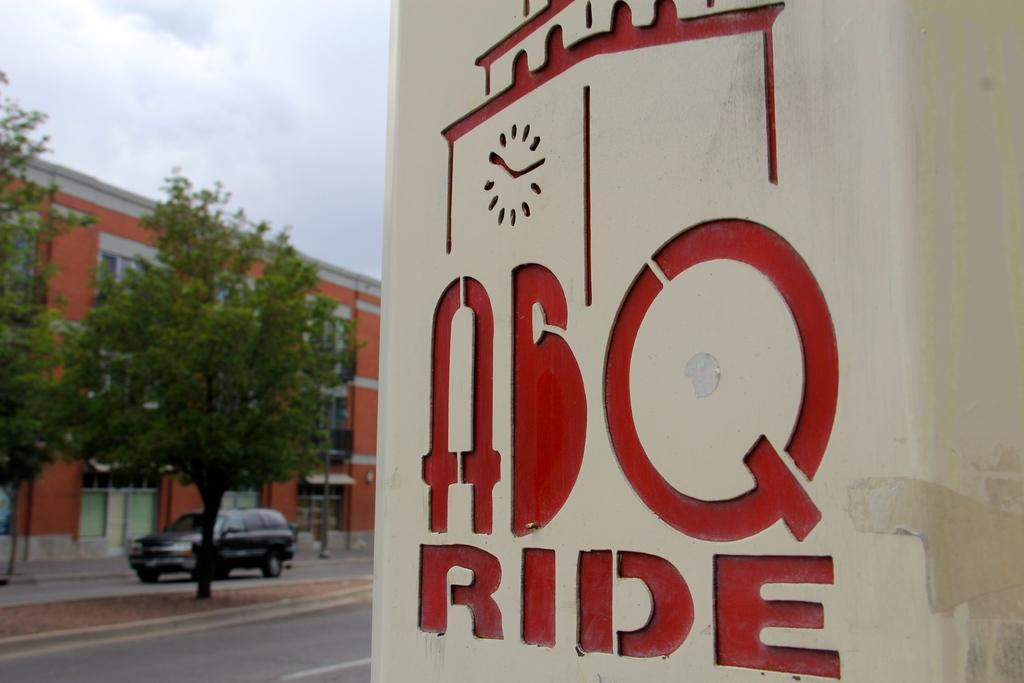What is written on the wall in the image? There is red writing on the wall in the image. What type of natural elements can be seen in the image? There are trees in the image. What type of structure is present in the image? There is a building in the image. Where is the vehicle located in the image? The vehicle is in the left corner of the image. What type of twig is being used to clean the vehicle in the image? There is no twig present in the image, nor is there any indication of cleaning. Can you see a sponge being used to wash the red writing on the wall in the image? There is no sponge present in the image, and the red writing on the wall is not being washed. 